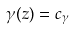Convert formula to latex. <formula><loc_0><loc_0><loc_500><loc_500>\gamma ( z ) = c _ { \gamma }</formula> 